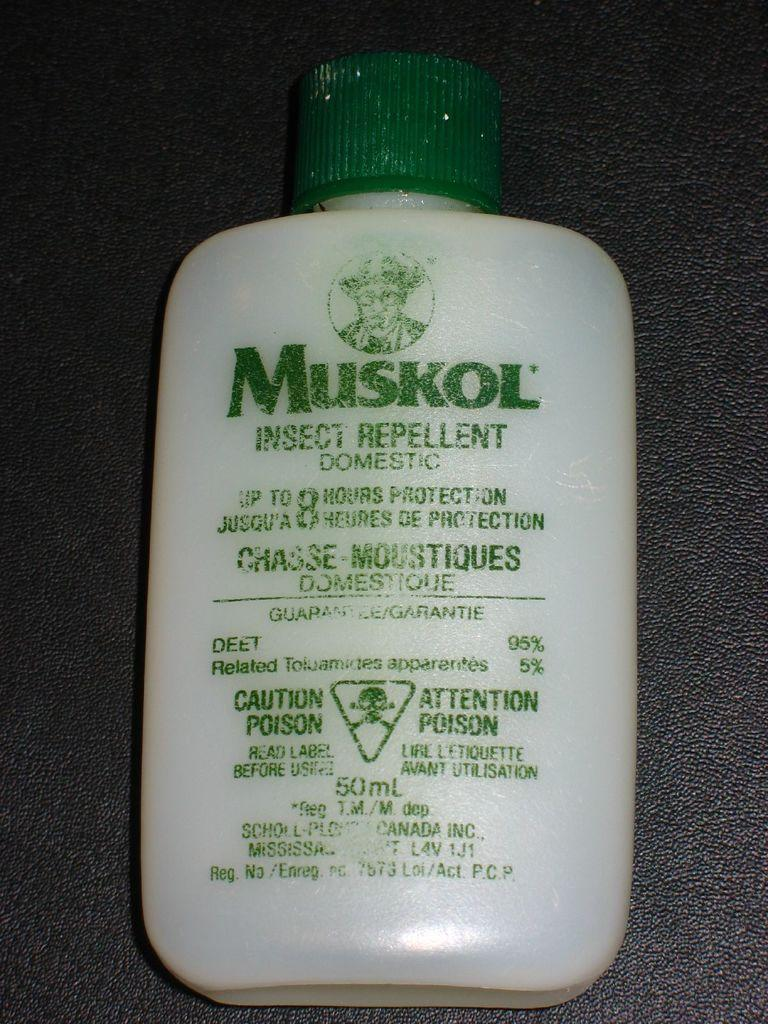<image>
Render a clear and concise summary of the photo. Insect repellent bottle from the maker Muskol that provides up to 8 hours of protection. 